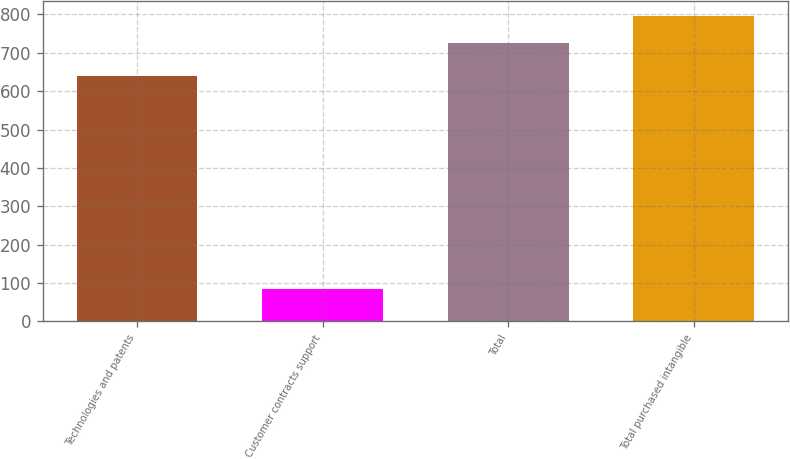Convert chart. <chart><loc_0><loc_0><loc_500><loc_500><bar_chart><fcel>Technologies and patents<fcel>Customer contracts support<fcel>Total<fcel>Total purchased intangible<nl><fcel>640.3<fcel>83.6<fcel>725.9<fcel>795.03<nl></chart> 